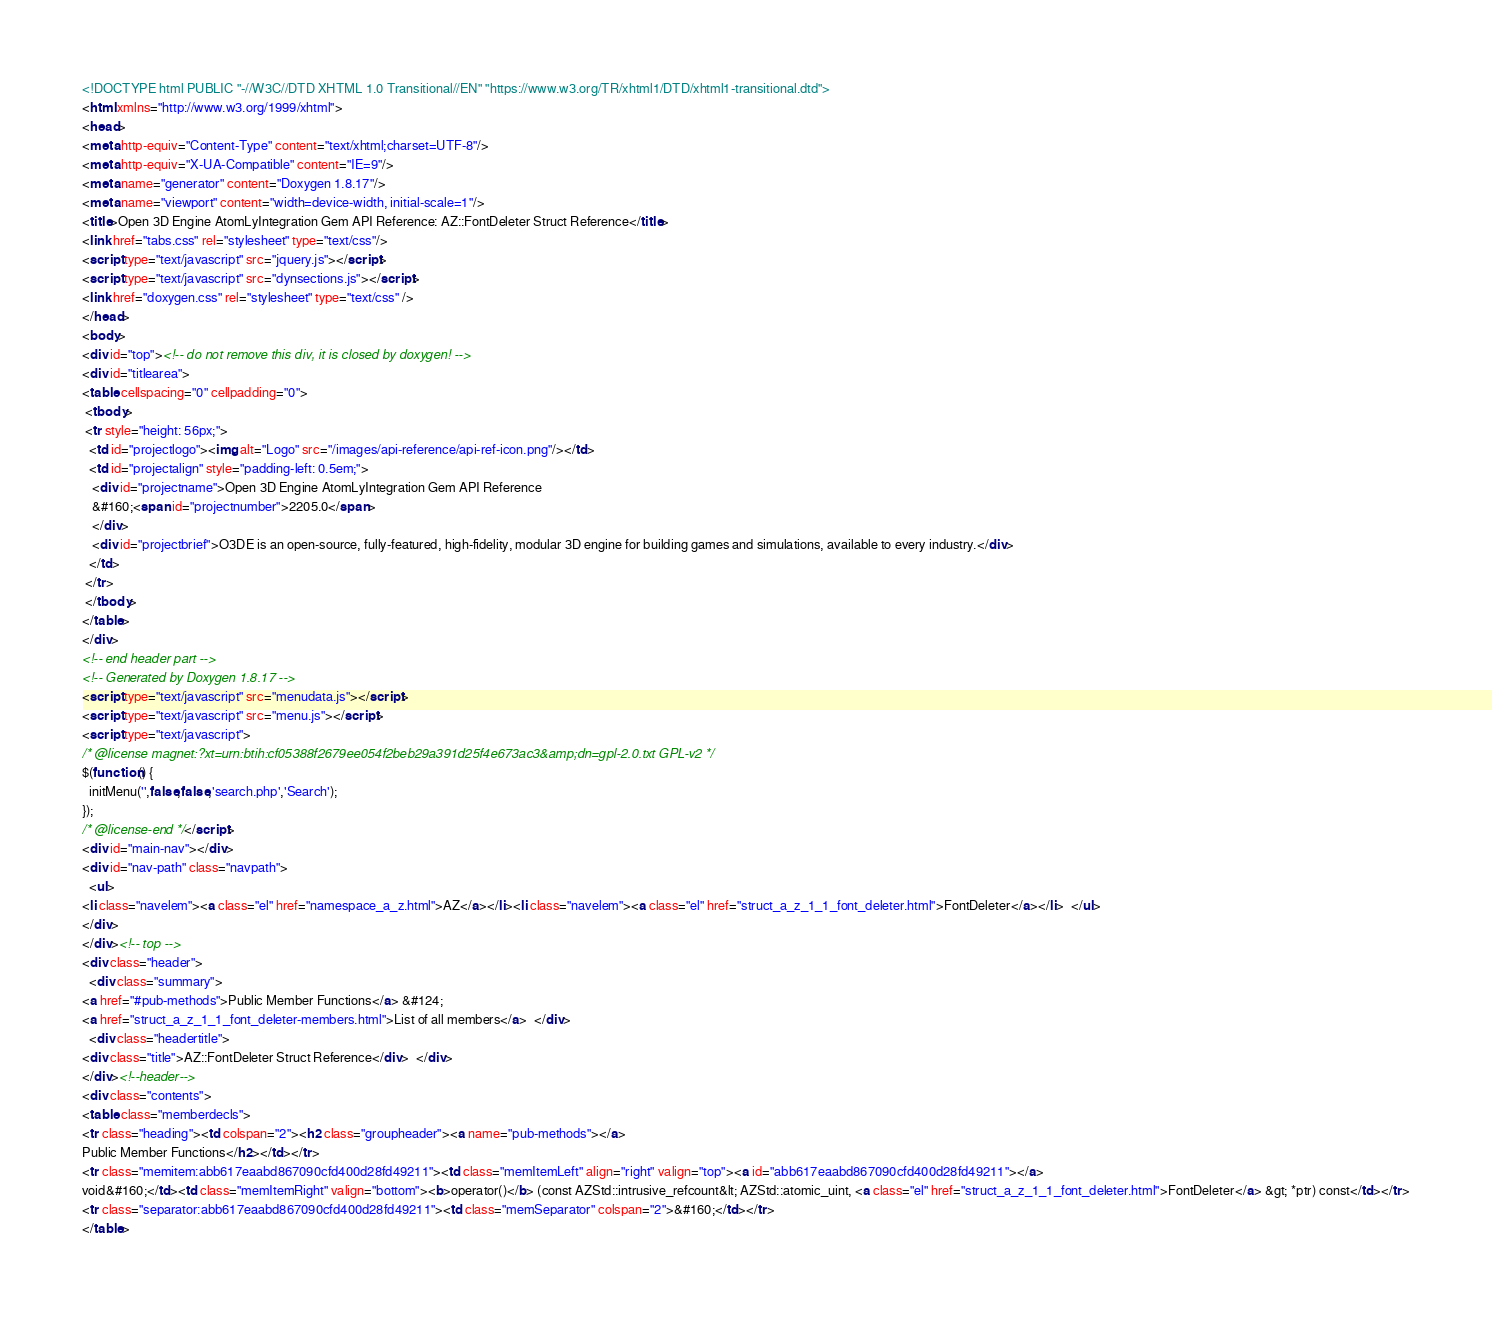<code> <loc_0><loc_0><loc_500><loc_500><_HTML_><!DOCTYPE html PUBLIC "-//W3C//DTD XHTML 1.0 Transitional//EN" "https://www.w3.org/TR/xhtml1/DTD/xhtml1-transitional.dtd">
<html xmlns="http://www.w3.org/1999/xhtml">
<head>
<meta http-equiv="Content-Type" content="text/xhtml;charset=UTF-8"/>
<meta http-equiv="X-UA-Compatible" content="IE=9"/>
<meta name="generator" content="Doxygen 1.8.17"/>
<meta name="viewport" content="width=device-width, initial-scale=1"/>
<title>Open 3D Engine AtomLyIntegration Gem API Reference: AZ::FontDeleter Struct Reference</title>
<link href="tabs.css" rel="stylesheet" type="text/css"/>
<script type="text/javascript" src="jquery.js"></script>
<script type="text/javascript" src="dynsections.js"></script>
<link href="doxygen.css" rel="stylesheet" type="text/css" />
</head>
<body>
<div id="top"><!-- do not remove this div, it is closed by doxygen! -->
<div id="titlearea">
<table cellspacing="0" cellpadding="0">
 <tbody>
 <tr style="height: 56px;">
  <td id="projectlogo"><img alt="Logo" src="/images/api-reference/api-ref-icon.png"/></td>
  <td id="projectalign" style="padding-left: 0.5em;">
   <div id="projectname">Open 3D Engine AtomLyIntegration Gem API Reference
   &#160;<span id="projectnumber">2205.0</span>
   </div>
   <div id="projectbrief">O3DE is an open-source, fully-featured, high-fidelity, modular 3D engine for building games and simulations, available to every industry.</div>
  </td>
 </tr>
 </tbody>
</table>
</div>
<!-- end header part -->
<!-- Generated by Doxygen 1.8.17 -->
<script type="text/javascript" src="menudata.js"></script>
<script type="text/javascript" src="menu.js"></script>
<script type="text/javascript">
/* @license magnet:?xt=urn:btih:cf05388f2679ee054f2beb29a391d25f4e673ac3&amp;dn=gpl-2.0.txt GPL-v2 */
$(function() {
  initMenu('',false,false,'search.php','Search');
});
/* @license-end */</script>
<div id="main-nav"></div>
<div id="nav-path" class="navpath">
  <ul>
<li class="navelem"><a class="el" href="namespace_a_z.html">AZ</a></li><li class="navelem"><a class="el" href="struct_a_z_1_1_font_deleter.html">FontDeleter</a></li>  </ul>
</div>
</div><!-- top -->
<div class="header">
  <div class="summary">
<a href="#pub-methods">Public Member Functions</a> &#124;
<a href="struct_a_z_1_1_font_deleter-members.html">List of all members</a>  </div>
  <div class="headertitle">
<div class="title">AZ::FontDeleter Struct Reference</div>  </div>
</div><!--header-->
<div class="contents">
<table class="memberdecls">
<tr class="heading"><td colspan="2"><h2 class="groupheader"><a name="pub-methods"></a>
Public Member Functions</h2></td></tr>
<tr class="memitem:abb617eaabd867090cfd400d28fd49211"><td class="memItemLeft" align="right" valign="top"><a id="abb617eaabd867090cfd400d28fd49211"></a>
void&#160;</td><td class="memItemRight" valign="bottom"><b>operator()</b> (const AZStd::intrusive_refcount&lt; AZStd::atomic_uint, <a class="el" href="struct_a_z_1_1_font_deleter.html">FontDeleter</a> &gt; *ptr) const</td></tr>
<tr class="separator:abb617eaabd867090cfd400d28fd49211"><td class="memSeparator" colspan="2">&#160;</td></tr>
</table></code> 